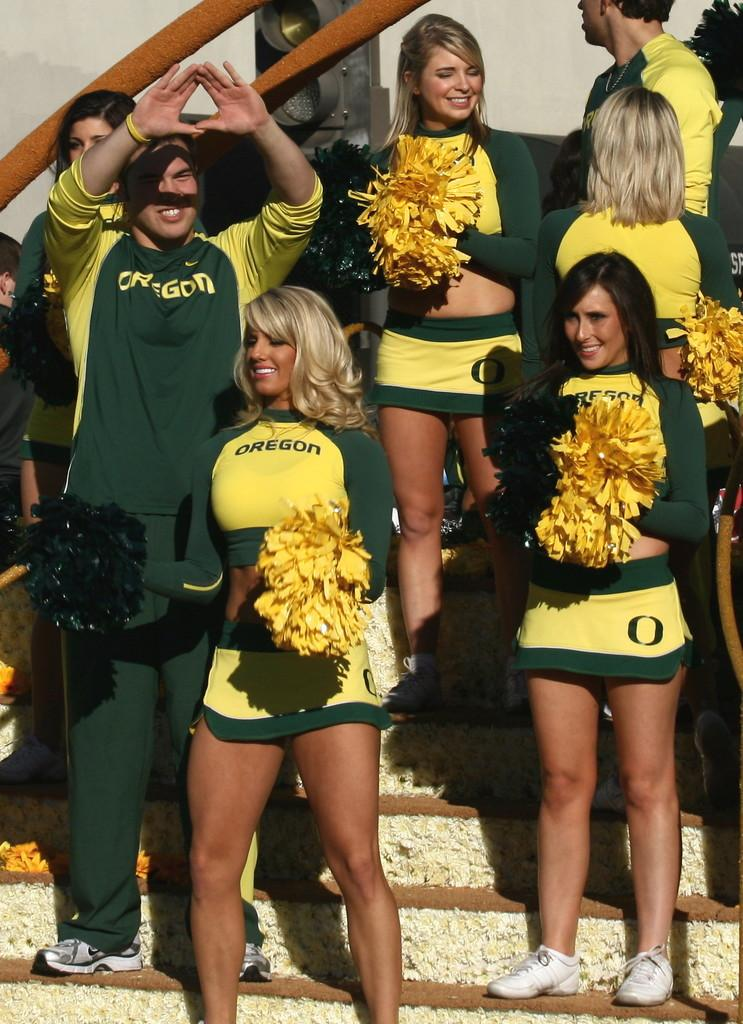Provide a one-sentence caption for the provided image. The cheerleaders from Oregon State University are watching the game and socializing. 